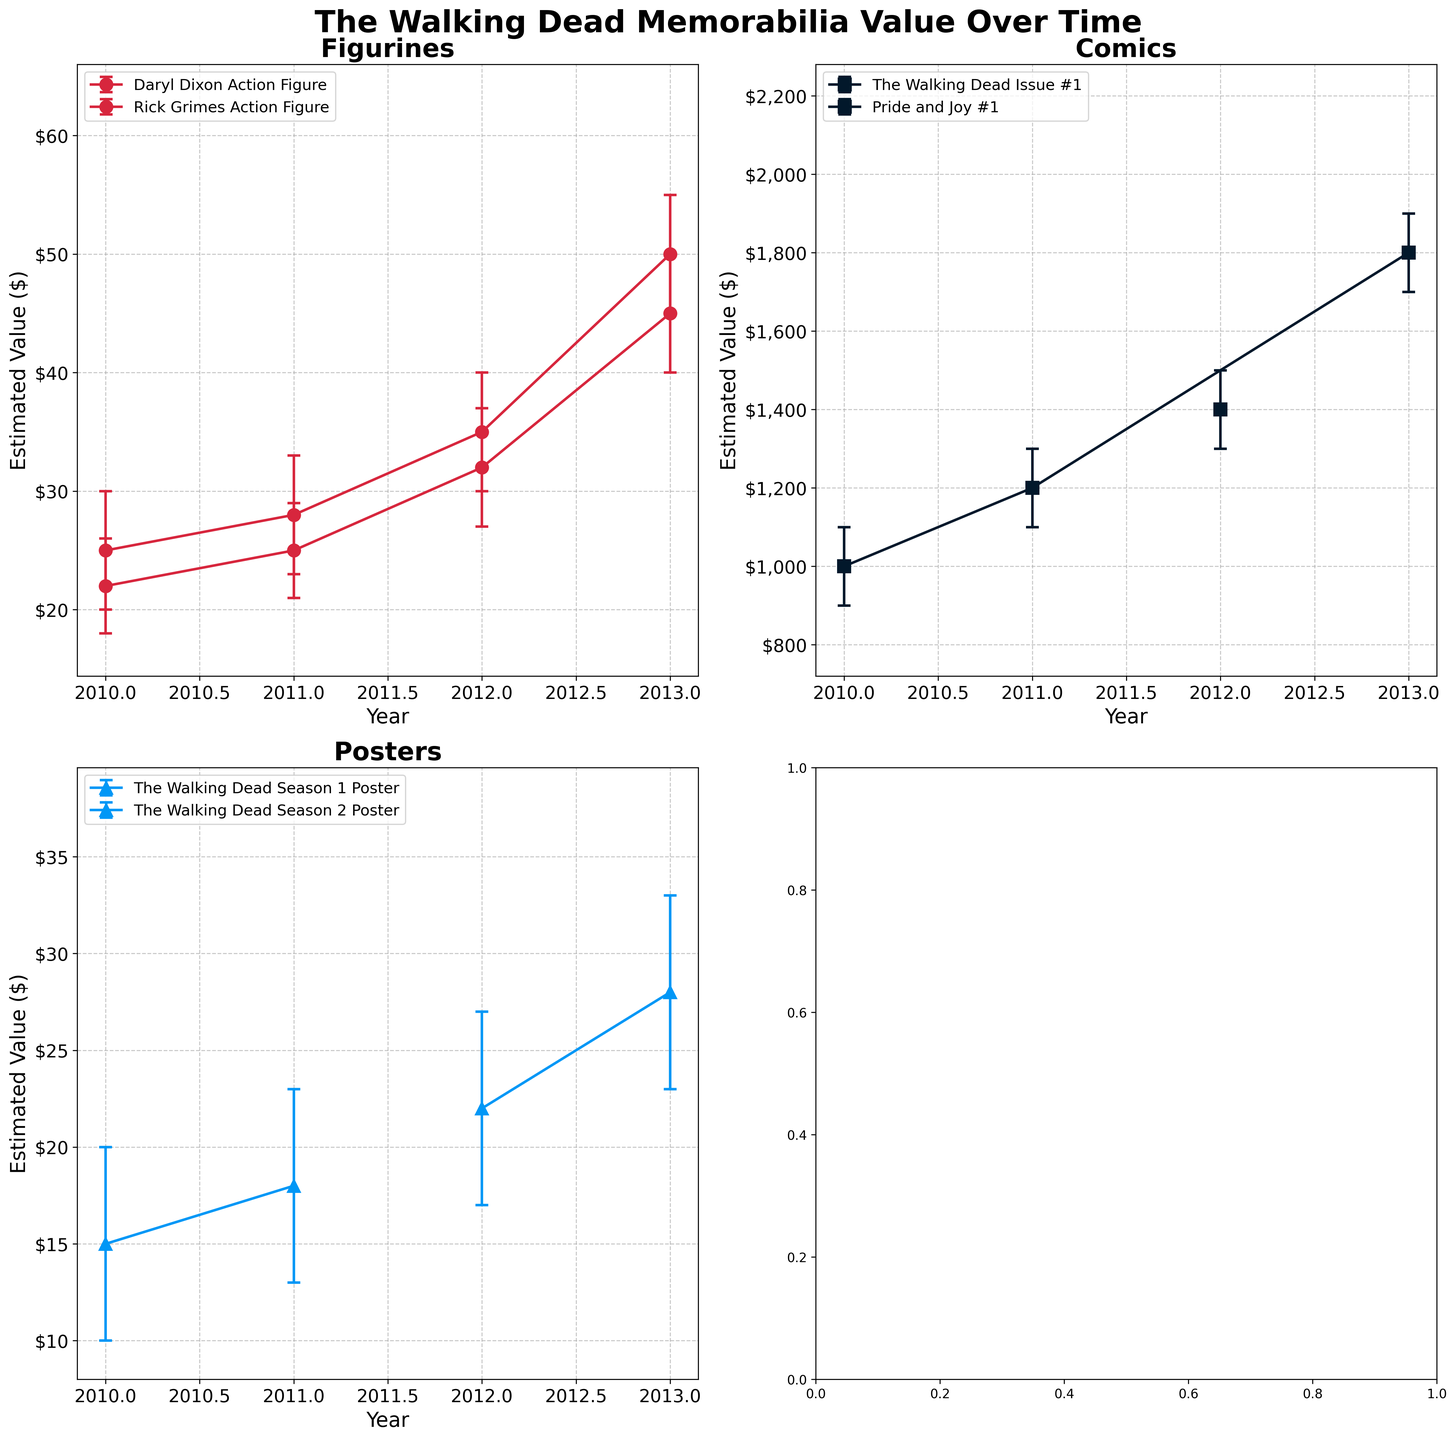What is the title of the figure? The title of the figure is usually displayed at the top of the plot. Here, it is clearly mentioned as "The Walking Dead Memorabilia Value Over Time".
Answer: The Walking Dead Memorabilia Value Over Time Which item type has the highest estimated value in 2013? To answer this, you need to look at the data points for 2013 in each subplot. The subplot for comics shows "The Walking Dead Issue #1" has an estimated value of $1800 in 2013, which is the highest among all item types.
Answer: Comics Between which years did the value of "Daryl Dixon Action Figure" increase the most? First, identify the values for "Daryl Dixon Action Figure" in each year (2010: $25, 2011: $28, 2012: $35, 2013: $50). Calculate the differences between consecutive years: $3 (2010 to 2011), $7 (2011 to 2012), and $15 (2012 to 2013). The largest increase is between 2012 and 2013.
Answer: 2012 and 2013 Which individual item shows the largest confidence interval in any year? Look for the item with the broadest range between the lower and upper confidence intervals. "The Walking Dead Issue #1 (Comic)" in 2013 has a confidence interval range from $1700 to $1900, which is a range of $200.
Answer: The Walking Dead Issue #1 (Comic) How has the estimated value of "The Walking Dead Season 2 Poster" changed over the years? Check the values in 2012 and 2013 for "The Walking Dead Season 2 Poster". In 2012, the value is $22, and in 2013, it is $28. Subtract to find the change: $28 - $22 = $6, indicating an increase of $6 over the years.
Answer: It has increased by $6 Which item among the figurines had a higher initial value in 2010? Compare the initial values of the two figurines in 2010. "Daryl Dixon Action Figure" is $25 while "Rick Grimes Action Figure" is $22. "Daryl Dixon Action Figure" had a higher initial value.
Answer: Daryl Dixon Action Figure What is the range of estimated values for "Rick Grimes Action Figure" in 2012? In 2012, the mean value is $32 with a lower confidence interval of $27 and an upper confidence interval of $37. The range is $37 - $27 = $10.
Answer: $10 How does the estimated value trend of posters compare to that of comics? Examine the trend lines for both posters and comics over the four years. Generally, both show an increasing trend, but the increase in value for comics is significantly larger compared to that of posters.
Answer: Comics increase more significantly than posters Which year shows the highest mean value for "The Walking Dead Issue #1" comic? Check the mean values for "The Walking Dead Issue #1" comic over the years 2010, 2011, and 2013. The highest value is in 2013 at $1800.
Answer: 2013 What is the confidence interval for "Daryl Dixon Action Figure" in 2013, and how would you interpret it? In 2013, the lower confidence interval is $45 and the upper confidence interval is $55, resulting in a CI of $45 to $55. This means we can be confident that the true value falls within this range.
Answer: $45 to $55 